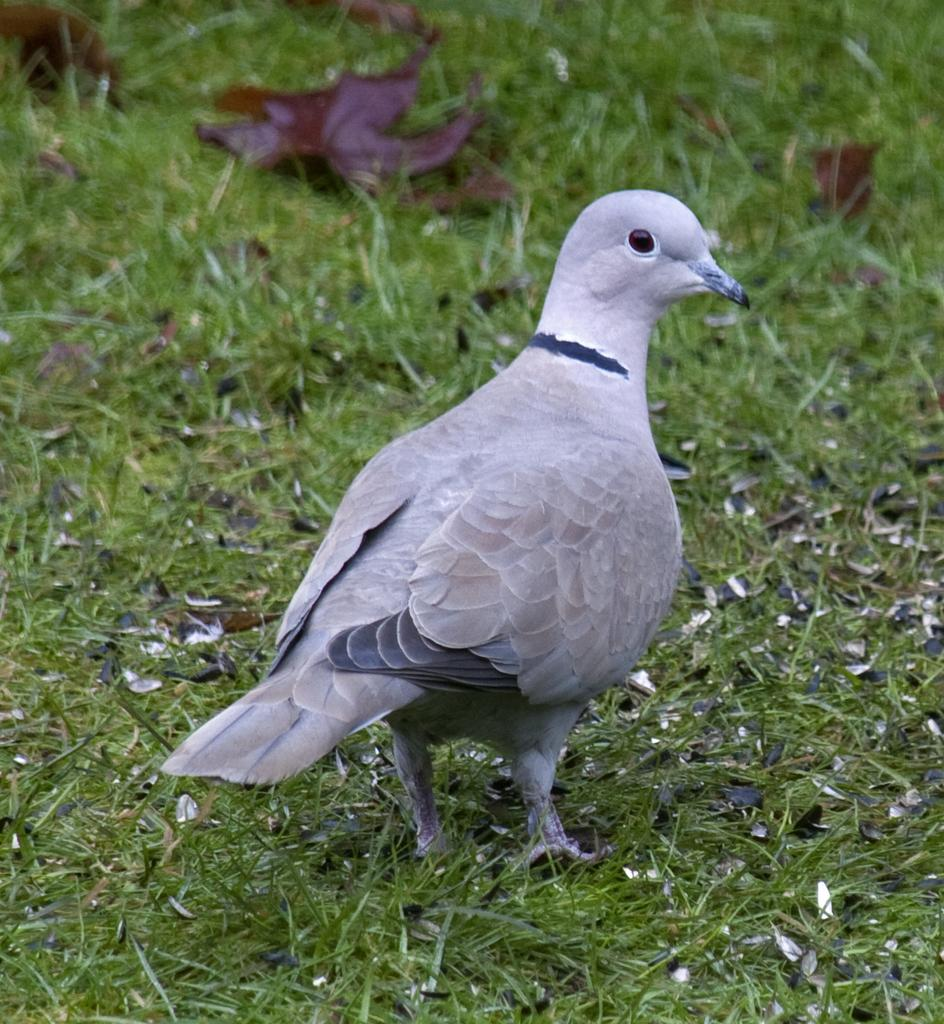What is the main subject of the image? There is a pigeon in the center of the image. What type of environment is visible in the image? There is grass visible at the bottom of the image. Is there a stream running through the wilderness in the image? There is no wilderness or stream present in the image; it features a pigeon and grass. 